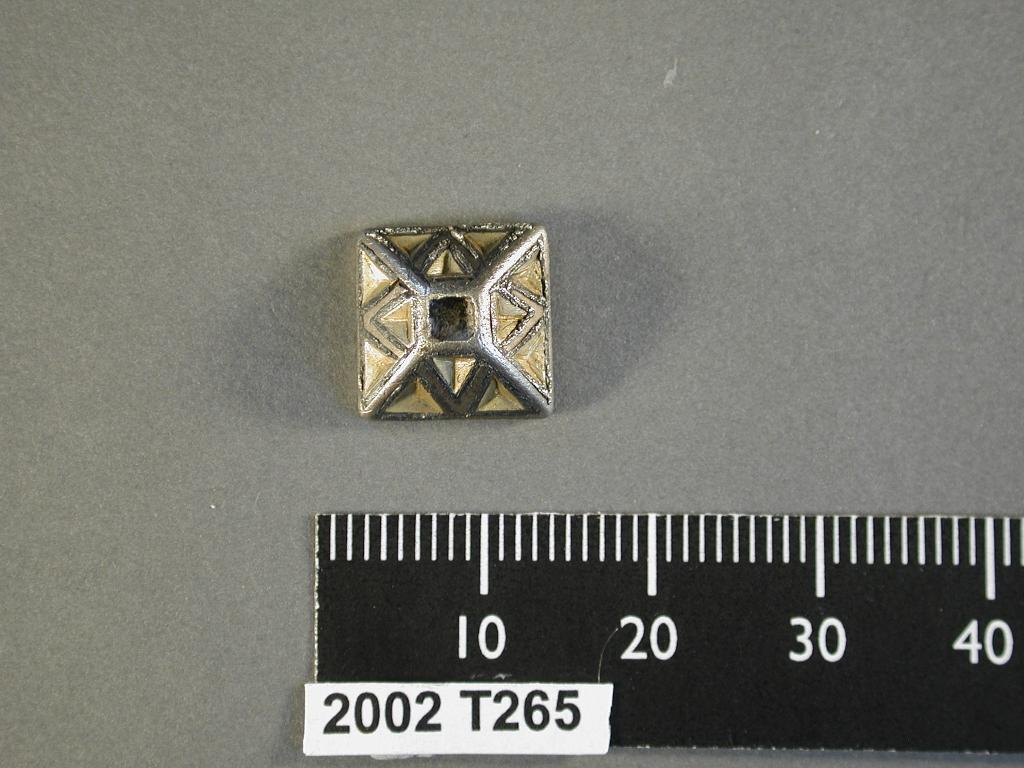Provide a one-sentence caption for the provided image. A ruler labeled 2002 T265 lays next to a gold colored pyramid shaped object. 